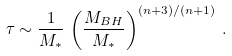Convert formula to latex. <formula><loc_0><loc_0><loc_500><loc_500>\tau \sim \frac { 1 } { M _ { * } } \, \left ( \frac { M _ { B H } } { M _ { * } } \right ) ^ { ( n + 3 ) / ( n + 1 ) } \, .</formula> 